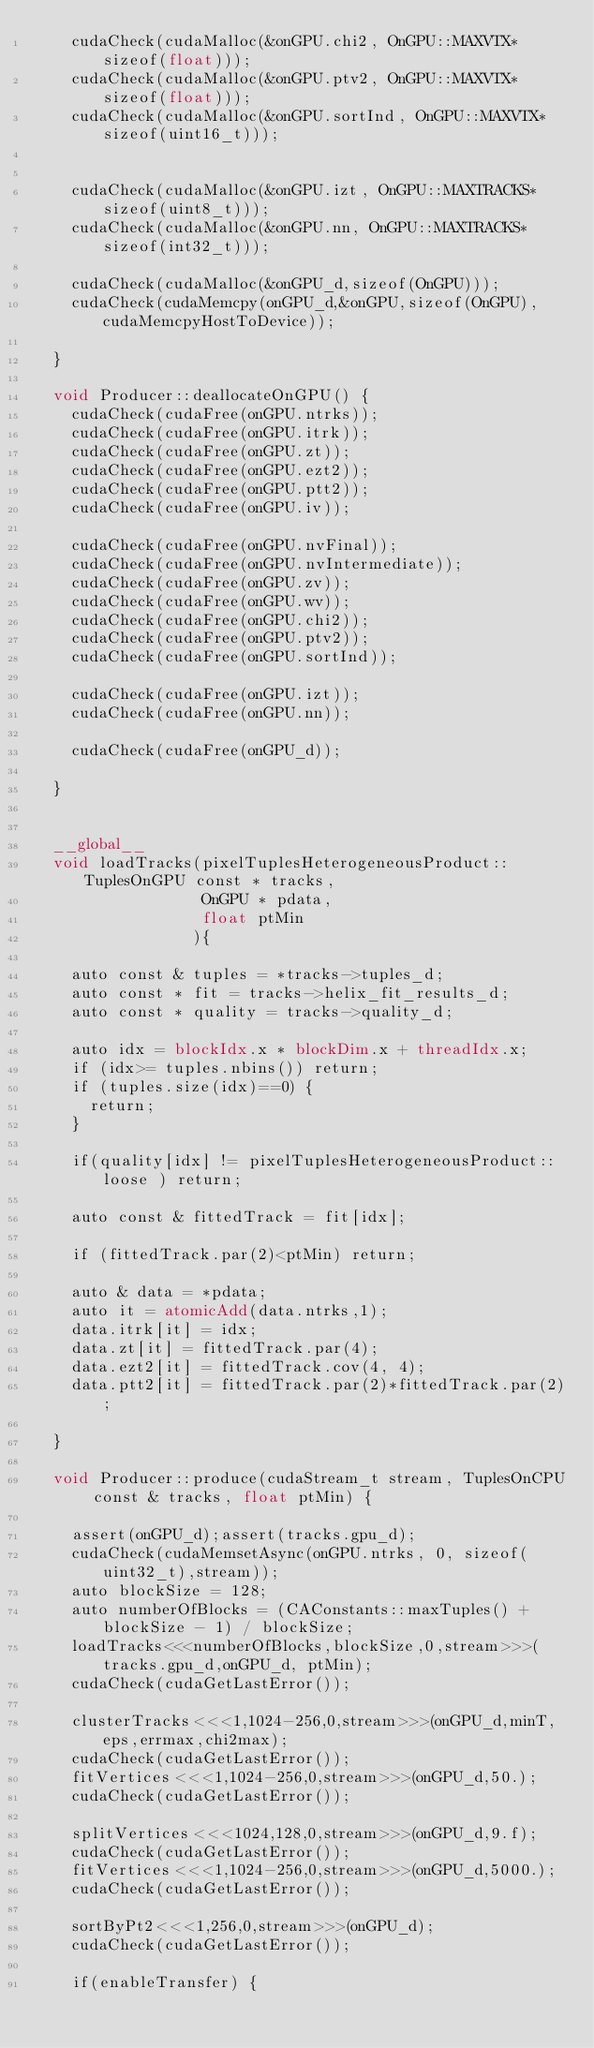<code> <loc_0><loc_0><loc_500><loc_500><_Cuda_>    cudaCheck(cudaMalloc(&onGPU.chi2, OnGPU::MAXVTX*sizeof(float)));
    cudaCheck(cudaMalloc(&onGPU.ptv2, OnGPU::MAXVTX*sizeof(float)));
    cudaCheck(cudaMalloc(&onGPU.sortInd, OnGPU::MAXVTX*sizeof(uint16_t)));


    cudaCheck(cudaMalloc(&onGPU.izt, OnGPU::MAXTRACKS*sizeof(uint8_t)));
    cudaCheck(cudaMalloc(&onGPU.nn, OnGPU::MAXTRACKS*sizeof(int32_t)));

    cudaCheck(cudaMalloc(&onGPU_d,sizeof(OnGPU)));
    cudaCheck(cudaMemcpy(onGPU_d,&onGPU,sizeof(OnGPU),cudaMemcpyHostToDevice));

  }
	      
  void Producer::deallocateOnGPU() {
    cudaCheck(cudaFree(onGPU.ntrks));
    cudaCheck(cudaFree(onGPU.itrk));
    cudaCheck(cudaFree(onGPU.zt));
    cudaCheck(cudaFree(onGPU.ezt2));
    cudaCheck(cudaFree(onGPU.ptt2));
    cudaCheck(cudaFree(onGPU.iv));

    cudaCheck(cudaFree(onGPU.nvFinal));
    cudaCheck(cudaFree(onGPU.nvIntermediate));
    cudaCheck(cudaFree(onGPU.zv));
    cudaCheck(cudaFree(onGPU.wv));
    cudaCheck(cudaFree(onGPU.chi2));
    cudaCheck(cudaFree(onGPU.ptv2));
    cudaCheck(cudaFree(onGPU.sortInd));

    cudaCheck(cudaFree(onGPU.izt));
    cudaCheck(cudaFree(onGPU.nn));

    cudaCheck(cudaFree(onGPU_d));

  }

  
  __global__
  void loadTracks(pixelTuplesHeterogeneousProduct::TuplesOnGPU const * tracks,
                  OnGPU * pdata,
                  float ptMin
                 ){

    auto const & tuples = *tracks->tuples_d;
    auto const * fit = tracks->helix_fit_results_d;
    auto const * quality = tracks->quality_d;

    auto idx = blockIdx.x * blockDim.x + threadIdx.x;
    if (idx>= tuples.nbins()) return;
    if (tuples.size(idx)==0) {
      return;
    }

    if(quality[idx] != pixelTuplesHeterogeneousProduct::loose ) return;

    auto const & fittedTrack = fit[idx];

    if (fittedTrack.par(2)<ptMin) return; 

    auto & data = *pdata;   
    auto it = atomicAdd(data.ntrks,1);
    data.itrk[it] = idx;
    data.zt[it] = fittedTrack.par(4);
    data.ezt2[it] = fittedTrack.cov(4, 4);
    data.ptt2[it] = fittedTrack.par(2)*fittedTrack.par(2);
 
  }

  void Producer::produce(cudaStream_t stream, TuplesOnCPU const & tracks, float ptMin) {
    
    assert(onGPU_d);assert(tracks.gpu_d);
    cudaCheck(cudaMemsetAsync(onGPU.ntrks, 0, sizeof(uint32_t),stream));
    auto blockSize = 128;
    auto numberOfBlocks = (CAConstants::maxTuples() + blockSize - 1) / blockSize;
    loadTracks<<<numberOfBlocks,blockSize,0,stream>>>(tracks.gpu_d,onGPU_d, ptMin);
    cudaCheck(cudaGetLastError());

    clusterTracks<<<1,1024-256,0,stream>>>(onGPU_d,minT,eps,errmax,chi2max);
    cudaCheck(cudaGetLastError());
    fitVertices<<<1,1024-256,0,stream>>>(onGPU_d,50.);
    cudaCheck(cudaGetLastError());

    splitVertices<<<1024,128,0,stream>>>(onGPU_d,9.f);
    cudaCheck(cudaGetLastError());
    fitVertices<<<1,1024-256,0,stream>>>(onGPU_d,5000.);
    cudaCheck(cudaGetLastError());

    sortByPt2<<<1,256,0,stream>>>(onGPU_d);
    cudaCheck(cudaGetLastError());

    if(enableTransfer) {</code> 